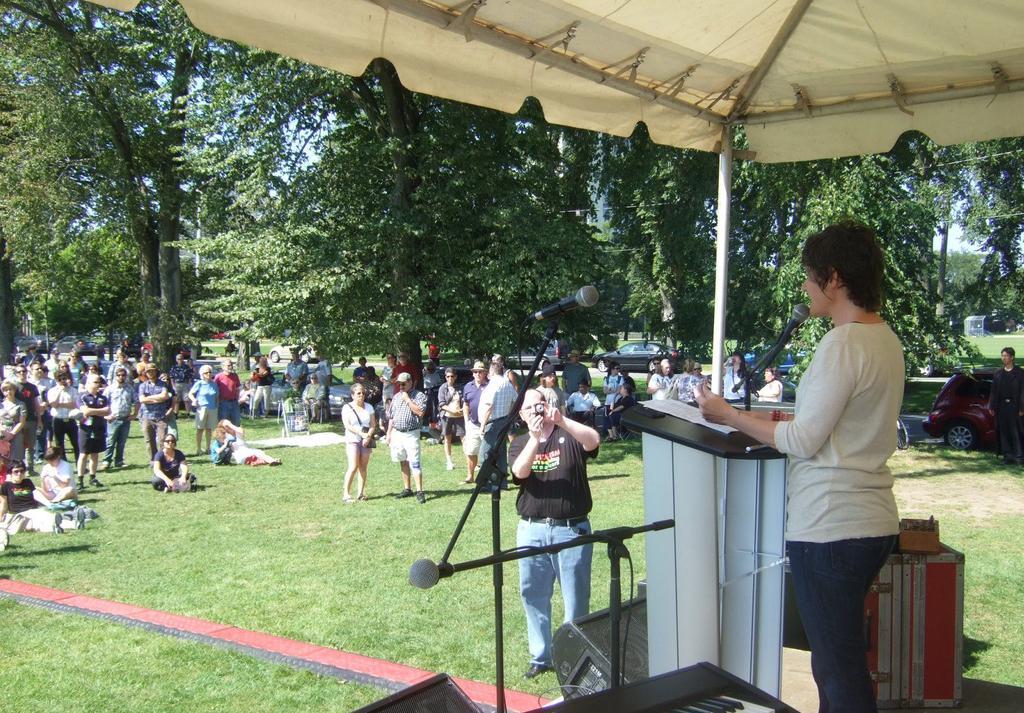Could you give a brief overview of what you see in this image? In this image I can see a person standing, in front of the microphone. Background I can see few other persons standing, trees in green color and sky in blue color. 